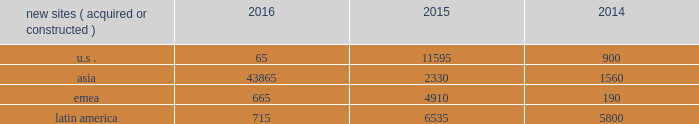In emerging markets , such as ghana , india , nigeria and uganda , wireless networks tend to be significantly less advanced than those in the united states , and initial voice networks continue to be deployed in underdeveloped areas .
A majority of consumers in these markets still utilize basic wireless services , predominantly on feature phones , while advanced device penetration remains low .
In more developed urban locations within these markets , early-stage data network deployments are underway .
Carriers are focused on completing voice network build-outs while also investing in initial data networks as wireless data usage and smartphone penetration within their customer bases begin to accelerate .
In markets with rapidly evolving network technology , such as south africa and most of the countries in latin america where we do business , initial voice networks , for the most part , have already been built out , and carriers are focused on 3g and 4g network build outs .
Consumers in these regions are increasingly adopting smartphones and other advanced devices , and , as a result , the usage of bandwidth-intensive mobile applications is growing materially .
Recent spectrum auctions in these rapidly evolving markets have allowed incumbent carriers to accelerate their data network deployments and have also enabled new entrants to begin initial investments in data networks .
Smartphone penetration and wireless data usage in these markets are growing rapidly , which typically requires that carriers continue to invest in their networks in order to maintain and augment their quality of service .
Finally , in markets with more mature network technology , such as germany and france , carriers are focused on deploying 4g data networks to account for rapidly increasing wireless data usage among their customer base .
With higher smartphone and advanced device penetration and significantly higher per capita data usage , carrier investment in networks is focused on 4g coverage and capacity .
We believe that the network technology migration we have seen in the united states , which has led to significantly denser networks and meaningful new business commencements for us over a number of years , will ultimately be replicated in our less advanced international markets .
As a result , we expect to be able to leverage our extensive international portfolio of approximately 104470 communications sites and the relationships we have built with our carrier customers to drive sustainable , long-term growth .
We have master lease agreements with certain of our tenants that provide for consistent , long-term revenue and reduce the likelihood of churn .
Our master lease agreements build and augment strong strategic partnerships with our tenants and have significantly reduced colocation cycle times , thereby providing our tenants with the ability to rapidly and efficiently deploy equipment on our sites .
Property operations new site revenue growth .
During the year ended december 31 , 2016 , we grew our portfolio of communications real estate through the acquisition and construction of approximately 45310 sites .
In a majority of our asia , emea and latin america markets , the revenue generated from newly acquired or constructed sites resulted in increases in both tenant and pass-through revenues ( such as ground rent or power and fuel costs ) and expenses .
We continue to evaluate opportunities to acquire communications real estate portfolios , both domestically and internationally , to determine whether they meet our risk-adjusted hurdle rates and whether we believe we can effectively integrate them into our existing portfolio. .
Property operations expenses .
Direct operating expenses incurred by our property segments include direct site level expenses and consist primarily of ground rent and power and fuel costs , some or all of which may be passed through to our tenants , as well as property taxes , repairs and maintenance .
These segment direct operating expenses exclude all segment and corporate selling , general , administrative and development expenses , which are aggregated into one line item entitled selling , general , administrative and development expense in our consolidated statements of operations .
In general , our property segments 2019 selling , general , administrative and development expenses do not significantly increase as a result of adding incremental tenants to our sites and typically increase only modestly year-over-year .
As a result , leasing additional space to new tenants on our sites provides significant incremental cash flow .
We may , however , incur additional segment selling , general , administrative and development expenses as we increase our presence in our existing markets or expand into new markets .
Our profit margin growth is therefore positively impacted by the addition of new tenants to our sites but can be temporarily diluted by our development activities. .
What is the total number of new sites acquired and constructed during 2016? 
Computations: (((65 + 43865) + 665) + 715)
Answer: 45310.0. 